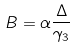Convert formula to latex. <formula><loc_0><loc_0><loc_500><loc_500>B = \alpha \frac { \Delta } { \gamma _ { 3 } }</formula> 